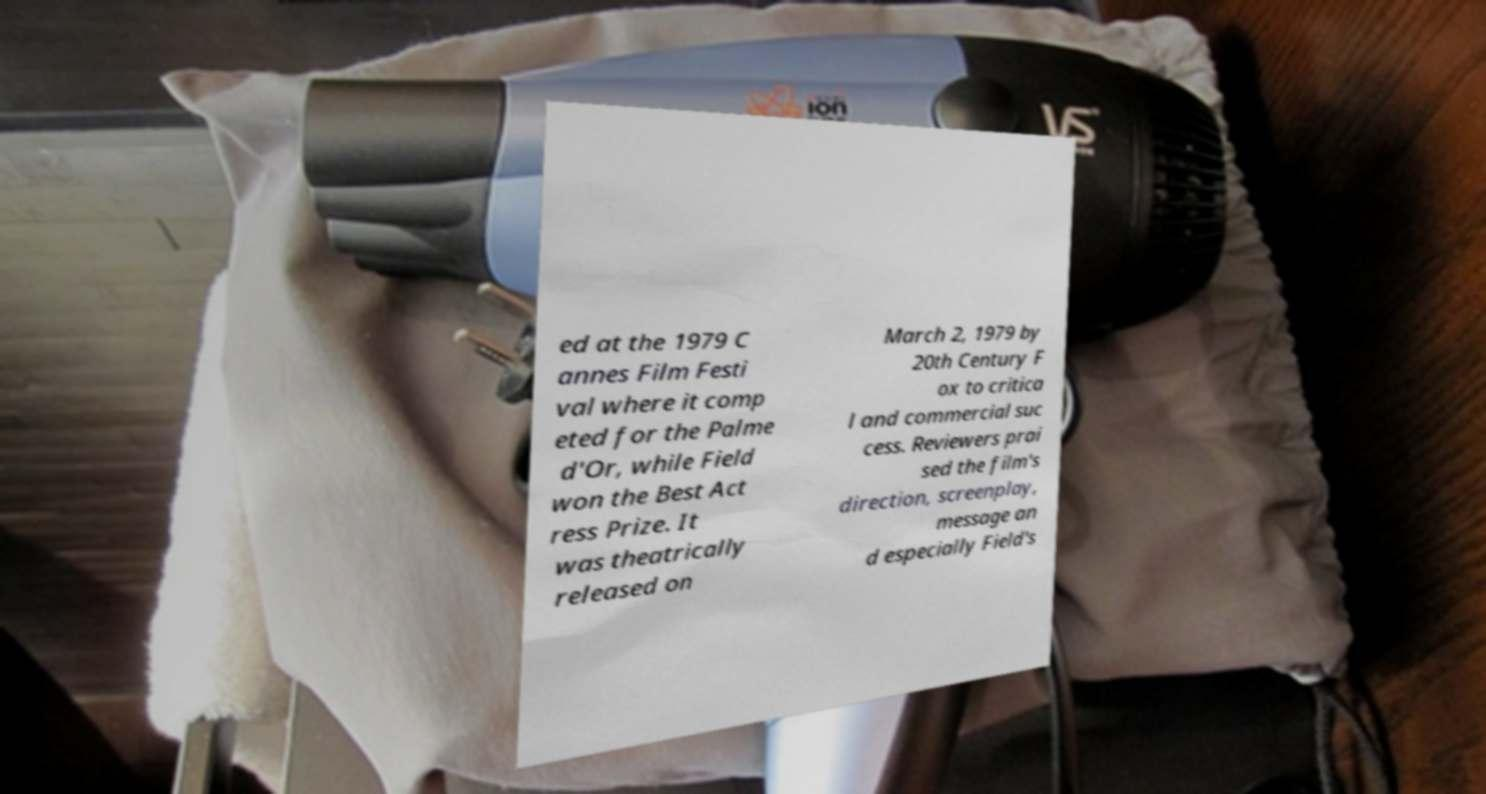Please read and relay the text visible in this image. What does it say? ed at the 1979 C annes Film Festi val where it comp eted for the Palme d'Or, while Field won the Best Act ress Prize. It was theatrically released on March 2, 1979 by 20th Century F ox to critica l and commercial suc cess. Reviewers prai sed the film's direction, screenplay, message an d especially Field's 